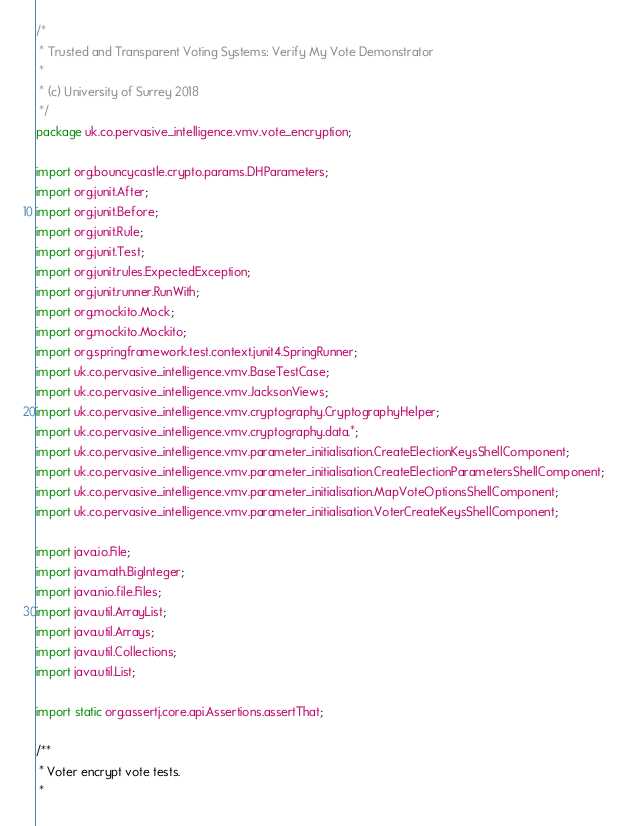Convert code to text. <code><loc_0><loc_0><loc_500><loc_500><_Java_>/*
 * Trusted and Transparent Voting Systems: Verify My Vote Demonstrator
 *
 * (c) University of Surrey 2018
 */
package uk.co.pervasive_intelligence.vmv.vote_encryption;

import org.bouncycastle.crypto.params.DHParameters;
import org.junit.After;
import org.junit.Before;
import org.junit.Rule;
import org.junit.Test;
import org.junit.rules.ExpectedException;
import org.junit.runner.RunWith;
import org.mockito.Mock;
import org.mockito.Mockito;
import org.springframework.test.context.junit4.SpringRunner;
import uk.co.pervasive_intelligence.vmv.BaseTestCase;
import uk.co.pervasive_intelligence.vmv.JacksonViews;
import uk.co.pervasive_intelligence.vmv.cryptography.CryptographyHelper;
import uk.co.pervasive_intelligence.vmv.cryptography.data.*;
import uk.co.pervasive_intelligence.vmv.parameter_initialisation.CreateElectionKeysShellComponent;
import uk.co.pervasive_intelligence.vmv.parameter_initialisation.CreateElectionParametersShellComponent;
import uk.co.pervasive_intelligence.vmv.parameter_initialisation.MapVoteOptionsShellComponent;
import uk.co.pervasive_intelligence.vmv.parameter_initialisation.VoterCreateKeysShellComponent;

import java.io.File;
import java.math.BigInteger;
import java.nio.file.Files;
import java.util.ArrayList;
import java.util.Arrays;
import java.util.Collections;
import java.util.List;

import static org.assertj.core.api.Assertions.assertThat;

/**
 * Voter encrypt vote tests.
 *</code> 